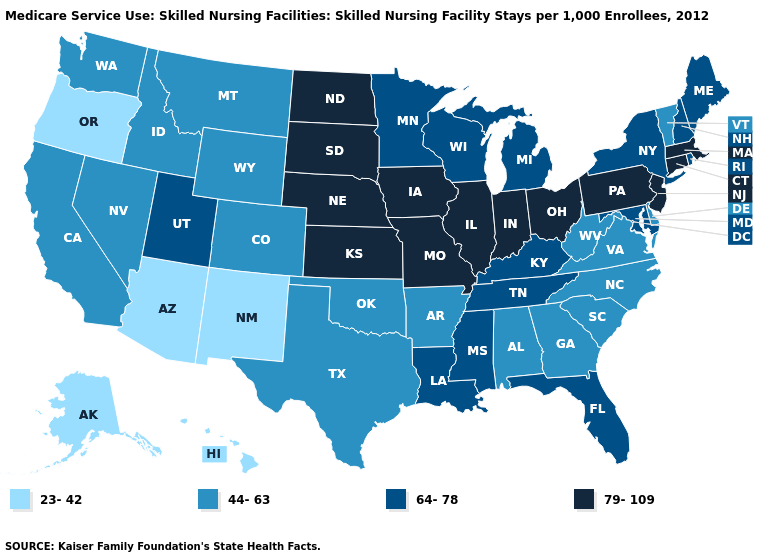Does Ohio have the same value as Arizona?
Answer briefly. No. Does Washington have the highest value in the West?
Quick response, please. No. Name the states that have a value in the range 23-42?
Concise answer only. Alaska, Arizona, Hawaii, New Mexico, Oregon. What is the value of New Hampshire?
Short answer required. 64-78. Name the states that have a value in the range 23-42?
Be succinct. Alaska, Arizona, Hawaii, New Mexico, Oregon. Does Oregon have the lowest value in the West?
Be succinct. Yes. Does Oklahoma have the same value as New Mexico?
Be succinct. No. Does Arizona have the lowest value in the USA?
Short answer required. Yes. Name the states that have a value in the range 79-109?
Answer briefly. Connecticut, Illinois, Indiana, Iowa, Kansas, Massachusetts, Missouri, Nebraska, New Jersey, North Dakota, Ohio, Pennsylvania, South Dakota. Which states hav the highest value in the MidWest?
Keep it brief. Illinois, Indiana, Iowa, Kansas, Missouri, Nebraska, North Dakota, Ohio, South Dakota. Does Louisiana have the highest value in the South?
Short answer required. Yes. Is the legend a continuous bar?
Short answer required. No. What is the highest value in the USA?
Quick response, please. 79-109. What is the value of Ohio?
Write a very short answer. 79-109. Does Virginia have the highest value in the USA?
Give a very brief answer. No. 